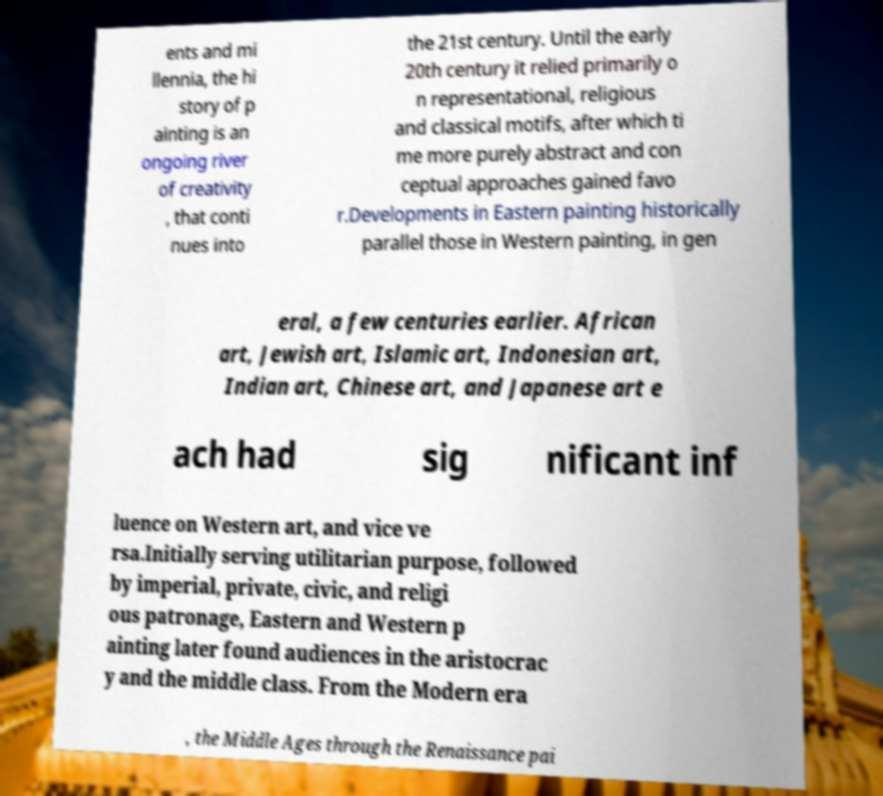Please identify and transcribe the text found in this image. ents and mi llennia, the hi story of p ainting is an ongoing river of creativity , that conti nues into the 21st century. Until the early 20th century it relied primarily o n representational, religious and classical motifs, after which ti me more purely abstract and con ceptual approaches gained favo r.Developments in Eastern painting historically parallel those in Western painting, in gen eral, a few centuries earlier. African art, Jewish art, Islamic art, Indonesian art, Indian art, Chinese art, and Japanese art e ach had sig nificant inf luence on Western art, and vice ve rsa.Initially serving utilitarian purpose, followed by imperial, private, civic, and religi ous patronage, Eastern and Western p ainting later found audiences in the aristocrac y and the middle class. From the Modern era , the Middle Ages through the Renaissance pai 